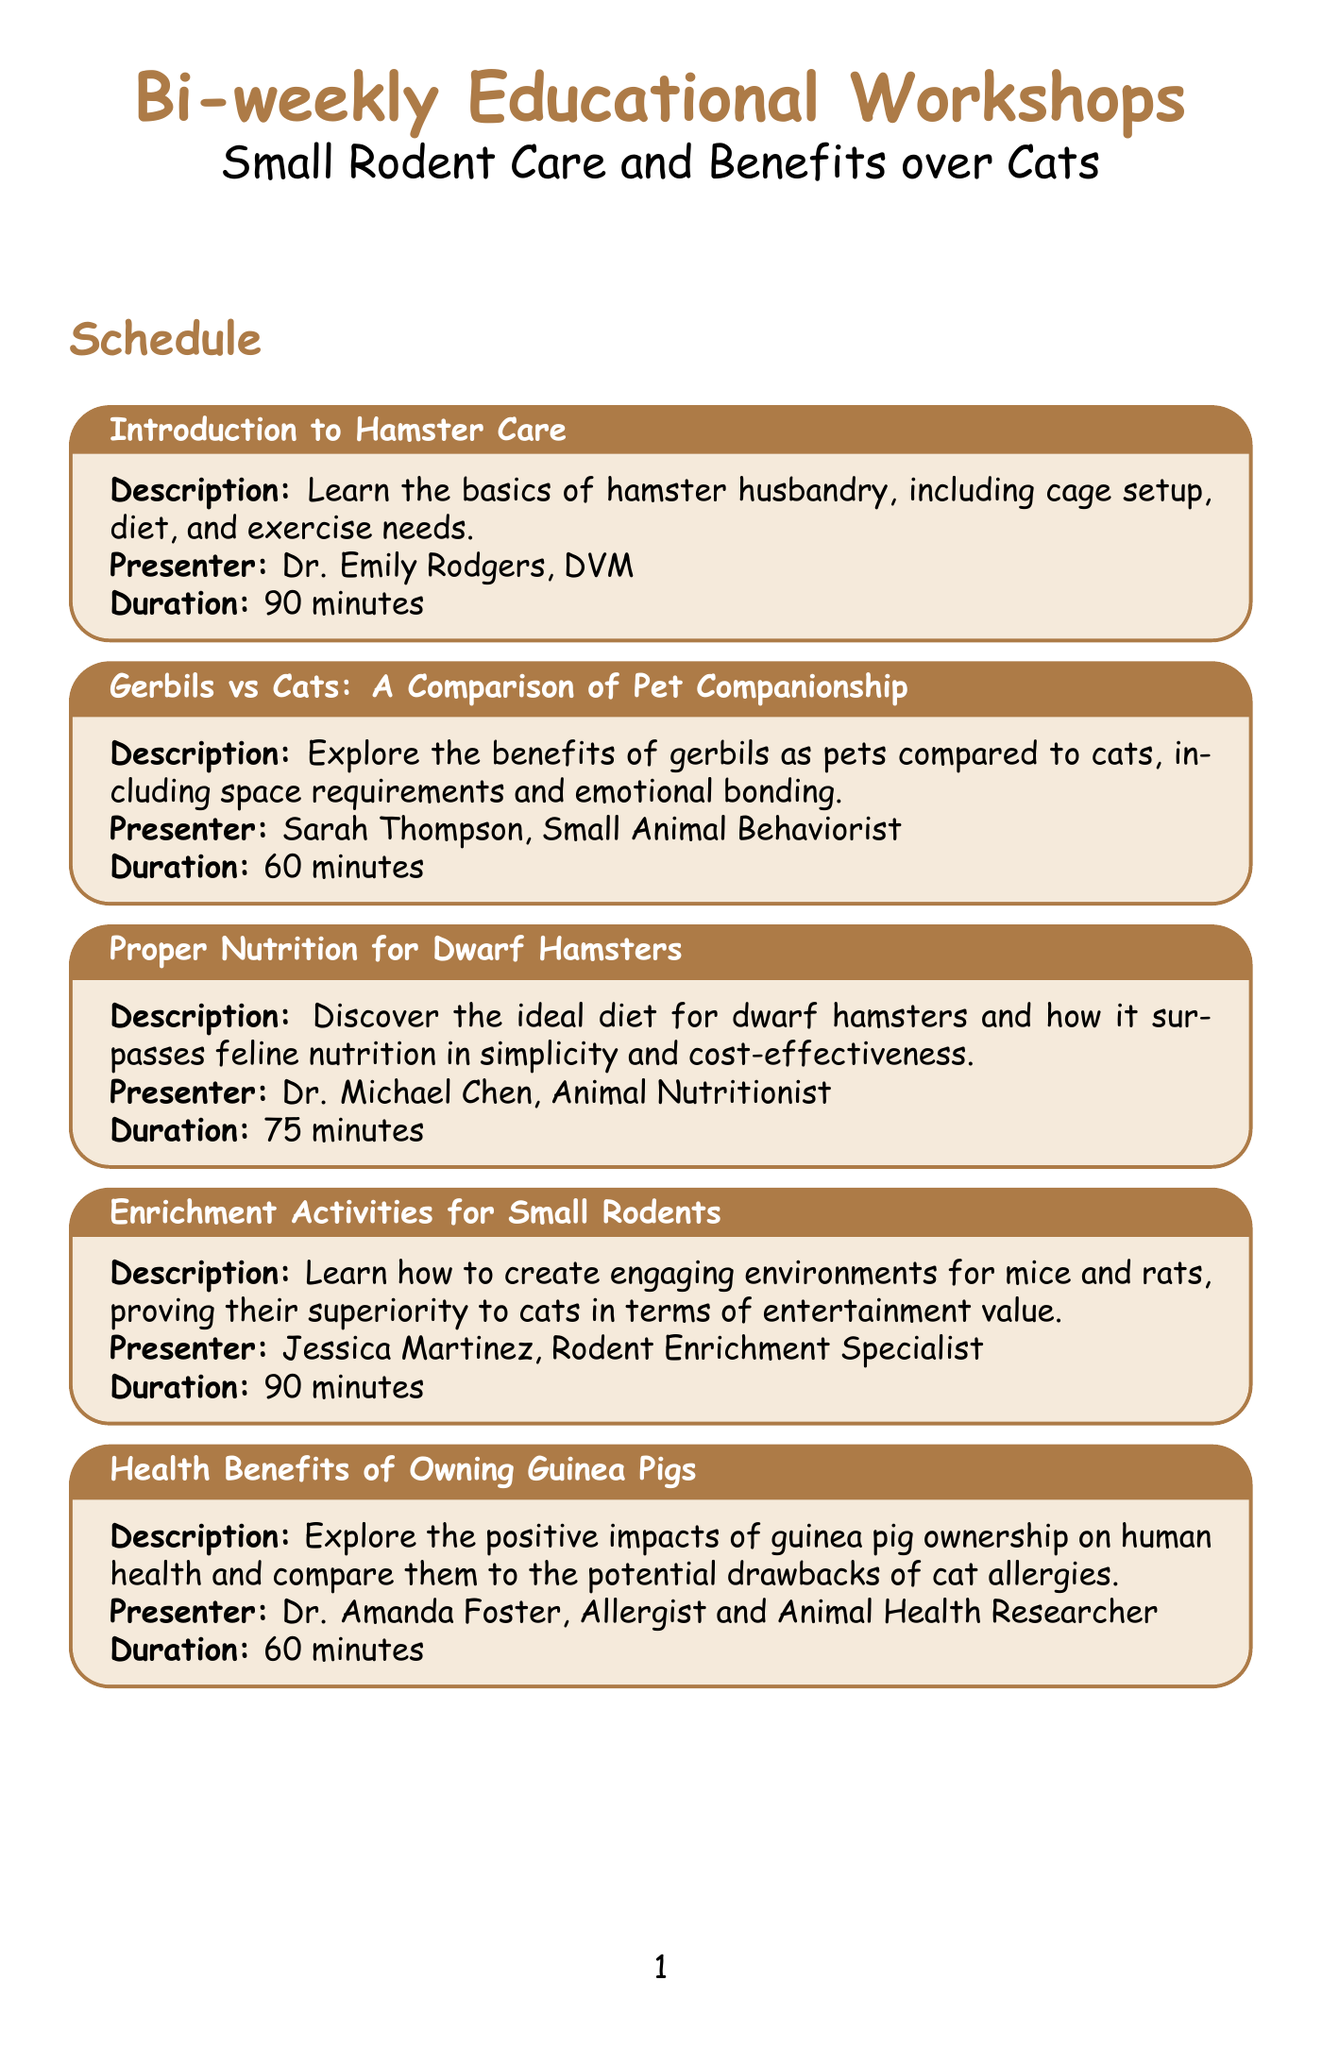What is the title of the first workshop? The title of the first workshop is listed clearly at the beginning of the schedule.
Answer: Introduction to Hamster Care Who is the presenter for the "Proper Nutrition for Dwarf Hamsters" workshop? The presenter's name is stated under the description of this specific workshop.
Answer: Dr. Michael Chen, Animal Nutritionist How long is the "Building the Perfect Chinchilla Habitat" workshop? The duration of this workshop is indicated right after the presenter’s name in the workshop details.
Answer: 120 minutes What is the main topic of the "Debunking Myths: Small Rodents vs Cats" workshop? The description provides insight into what the workshop will cover, focusing on small rodents and cats.
Answer: Common misconceptions about small rodents and cats Which workshop discusses the health benefits of owning guinea pigs? The title of the workshop is explicitly written in the schedule, highlighting the subject matter.
Answer: Health Benefits of Owning Guinea Pigs How many workshops last for 60 minutes? The durations listed in the document help determine how many workshops are categorized this way.
Answer: 3 Who specializes in rodent enrichment? This information is shared in the description of one of the workshops.
Answer: Jessica Martinez, Rodent Enrichment Specialist What type of pet ownership is analyzed in the workshop by Emma Davis? The title of the workshop indicates the comparison being made between different types of pets.
Answer: Cost-effectiveness of owning small rodents compared to cats 